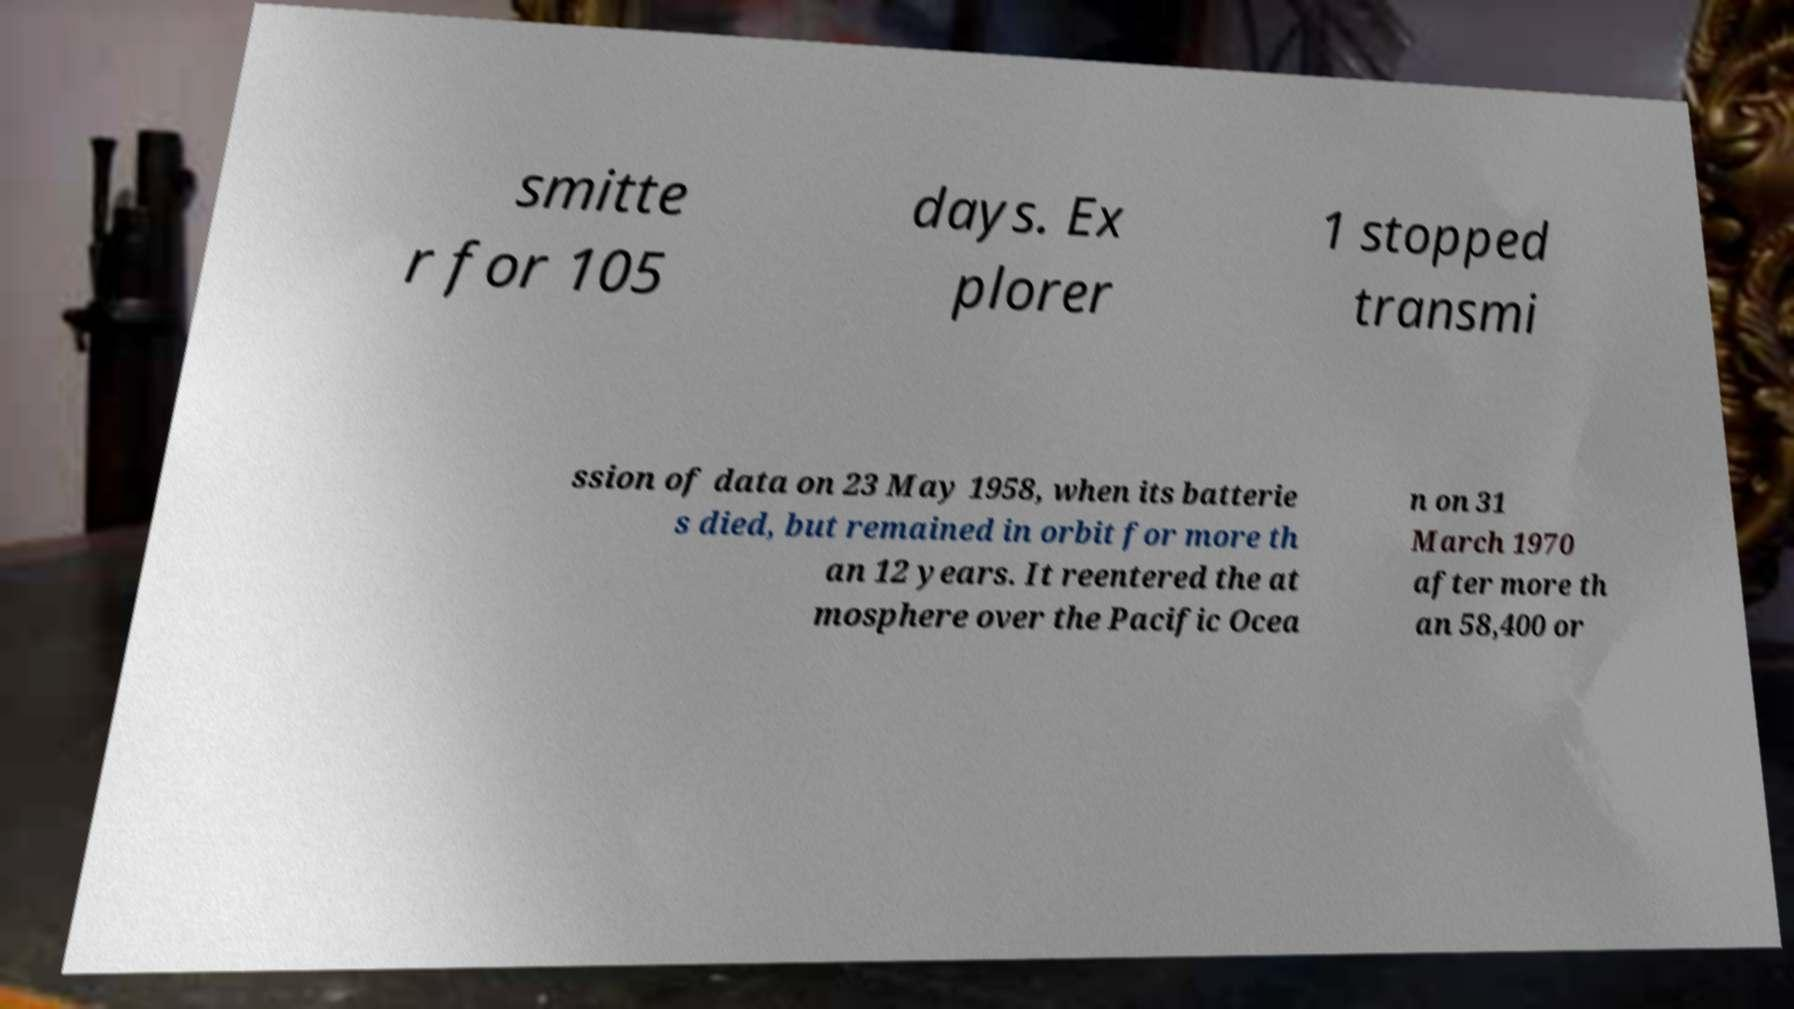There's text embedded in this image that I need extracted. Can you transcribe it verbatim? smitte r for 105 days. Ex plorer 1 stopped transmi ssion of data on 23 May 1958, when its batterie s died, but remained in orbit for more th an 12 years. It reentered the at mosphere over the Pacific Ocea n on 31 March 1970 after more th an 58,400 or 